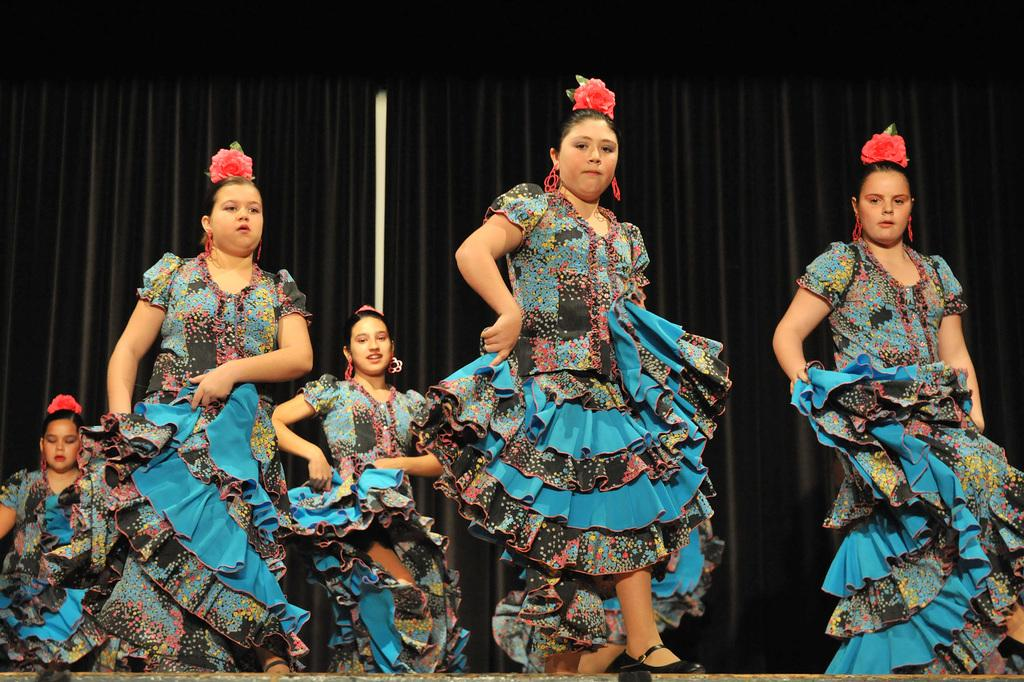What are the women in the image doing? The women in the image are dancing. Where are the women dancing? The women are dancing on a dais. What can be seen in the background of the image? There is a black cloth in the background of the image. What are the women wearing? All the women are wearing similar dresses. How many legs can be seen growing out of the dais in the image? There are no legs growing out of the dais in the image; it is a platform for the women to dance on. 